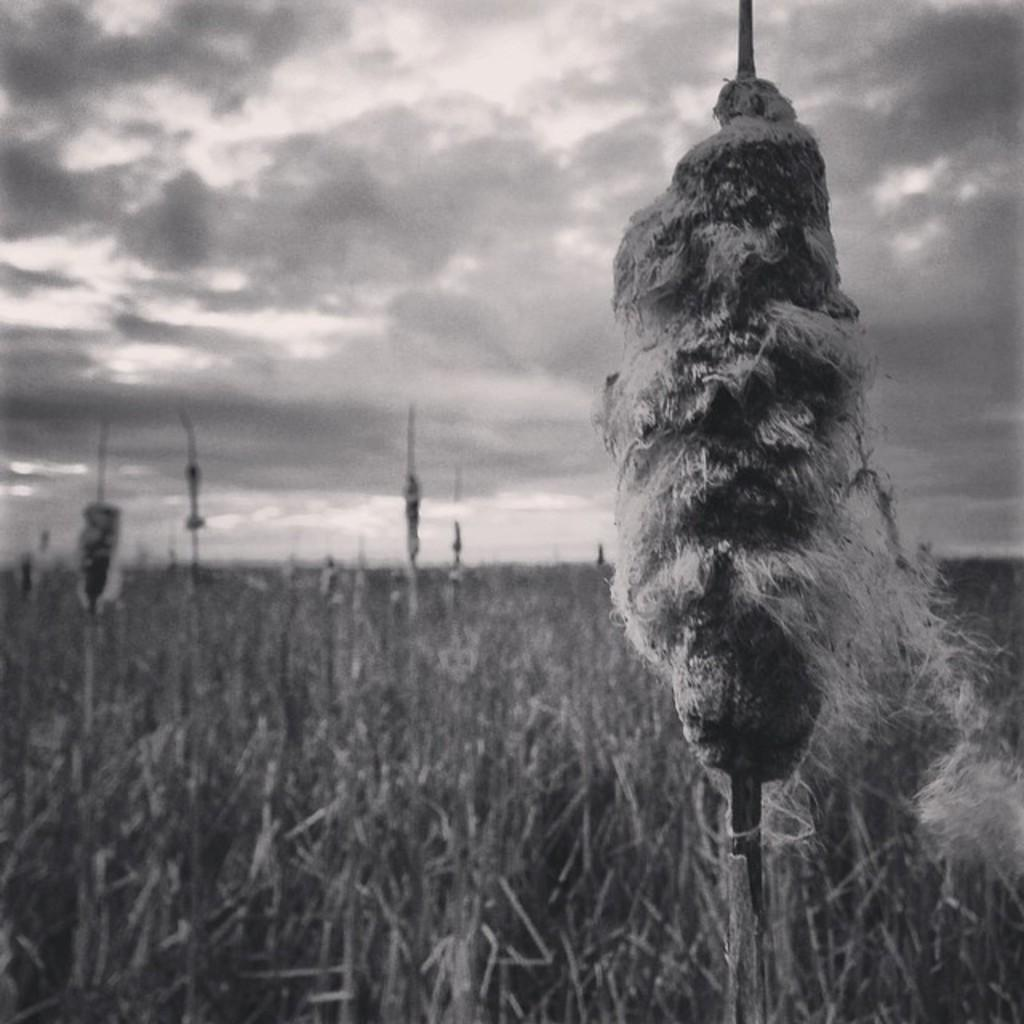What is the color scheme of the image? The image is black and white. What type of living organisms can be seen in the image? Plants can be seen in the image. What part of the natural environment is visible in the image? The sky is visible in the background of the image. What type of insurance policy is being discussed in the image? There is no indication in the image that any insurance policy is being discussed. Can you tell me who is talking to whom in the image? There is no conversation or interaction between individuals depicted in the image. What type of joke can be seen written on the plants in the image? There are no jokes or written text present on the plants in the image. 